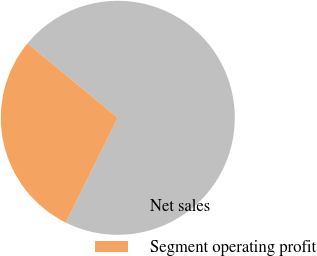<chart> <loc_0><loc_0><loc_500><loc_500><pie_chart><fcel>Net sales<fcel>Segment operating profit<nl><fcel>71.36%<fcel>28.64%<nl></chart> 